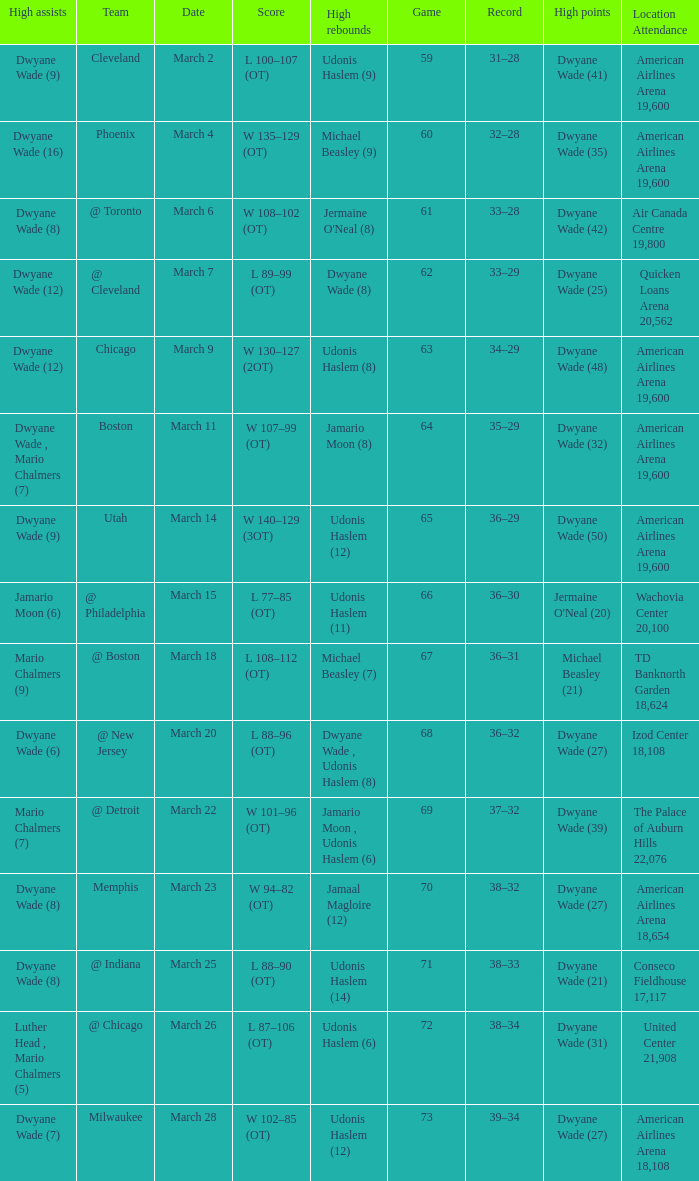Could you parse the entire table as a dict? {'header': ['High assists', 'Team', 'Date', 'Score', 'High rebounds', 'Game', 'Record', 'High points', 'Location Attendance'], 'rows': [['Dwyane Wade (9)', 'Cleveland', 'March 2', 'L 100–107 (OT)', 'Udonis Haslem (9)', '59', '31–28', 'Dwyane Wade (41)', 'American Airlines Arena 19,600'], ['Dwyane Wade (16)', 'Phoenix', 'March 4', 'W 135–129 (OT)', 'Michael Beasley (9)', '60', '32–28', 'Dwyane Wade (35)', 'American Airlines Arena 19,600'], ['Dwyane Wade (8)', '@ Toronto', 'March 6', 'W 108–102 (OT)', "Jermaine O'Neal (8)", '61', '33–28', 'Dwyane Wade (42)', 'Air Canada Centre 19,800'], ['Dwyane Wade (12)', '@ Cleveland', 'March 7', 'L 89–99 (OT)', 'Dwyane Wade (8)', '62', '33–29', 'Dwyane Wade (25)', 'Quicken Loans Arena 20,562'], ['Dwyane Wade (12)', 'Chicago', 'March 9', 'W 130–127 (2OT)', 'Udonis Haslem (8)', '63', '34–29', 'Dwyane Wade (48)', 'American Airlines Arena 19,600'], ['Dwyane Wade , Mario Chalmers (7)', 'Boston', 'March 11', 'W 107–99 (OT)', 'Jamario Moon (8)', '64', '35–29', 'Dwyane Wade (32)', 'American Airlines Arena 19,600'], ['Dwyane Wade (9)', 'Utah', 'March 14', 'W 140–129 (3OT)', 'Udonis Haslem (12)', '65', '36–29', 'Dwyane Wade (50)', 'American Airlines Arena 19,600'], ['Jamario Moon (6)', '@ Philadelphia', 'March 15', 'L 77–85 (OT)', 'Udonis Haslem (11)', '66', '36–30', "Jermaine O'Neal (20)", 'Wachovia Center 20,100'], ['Mario Chalmers (9)', '@ Boston', 'March 18', 'L 108–112 (OT)', 'Michael Beasley (7)', '67', '36–31', 'Michael Beasley (21)', 'TD Banknorth Garden 18,624'], ['Dwyane Wade (6)', '@ New Jersey', 'March 20', 'L 88–96 (OT)', 'Dwyane Wade , Udonis Haslem (8)', '68', '36–32', 'Dwyane Wade (27)', 'Izod Center 18,108'], ['Mario Chalmers (7)', '@ Detroit', 'March 22', 'W 101–96 (OT)', 'Jamario Moon , Udonis Haslem (6)', '69', '37–32', 'Dwyane Wade (39)', 'The Palace of Auburn Hills 22,076'], ['Dwyane Wade (8)', 'Memphis', 'March 23', 'W 94–82 (OT)', 'Jamaal Magloire (12)', '70', '38–32', 'Dwyane Wade (27)', 'American Airlines Arena 18,654'], ['Dwyane Wade (8)', '@ Indiana', 'March 25', 'L 88–90 (OT)', 'Udonis Haslem (14)', '71', '38–33', 'Dwyane Wade (21)', 'Conseco Fieldhouse 17,117'], ['Luther Head , Mario Chalmers (5)', '@ Chicago', 'March 26', 'L 87–106 (OT)', 'Udonis Haslem (6)', '72', '38–34', 'Dwyane Wade (31)', 'United Center 21,908'], ['Dwyane Wade (7)', 'Milwaukee', 'March 28', 'W 102–85 (OT)', 'Udonis Haslem (12)', '73', '39–34', 'Dwyane Wade (27)', 'American Airlines Arena 18,108']]} Who had the high point total against cleveland? Dwyane Wade (41). 